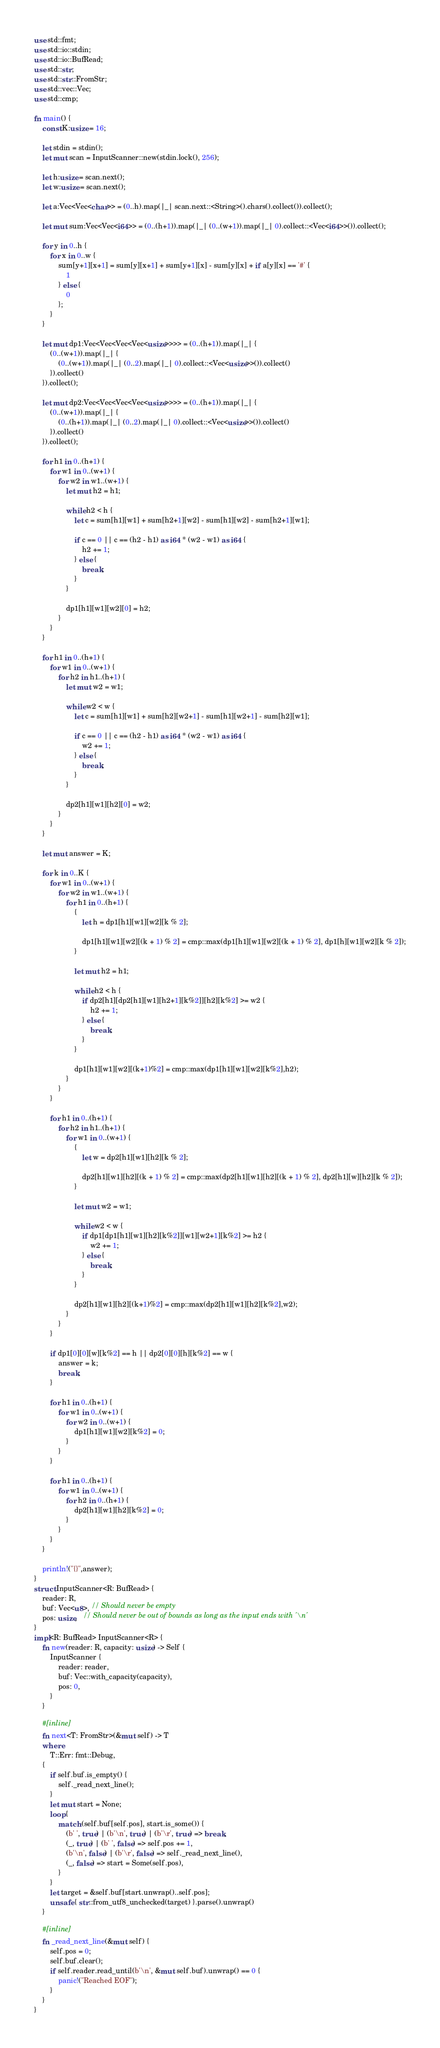Convert code to text. <code><loc_0><loc_0><loc_500><loc_500><_Rust_>use std::fmt;
use std::io::stdin;
use std::io::BufRead;
use std::str;
use std::str::FromStr;
use std::vec::Vec;
use std::cmp;

fn main() {
    const K:usize = 16;

    let stdin = stdin();
    let mut scan = InputScanner::new(stdin.lock(), 256);

    let h:usize = scan.next();
    let w:usize = scan.next();

    let a:Vec<Vec<char>> = (0..h).map(|_| scan.next::<String>().chars().collect()).collect();

    let mut sum:Vec<Vec<i64>> = (0..(h+1)).map(|_| (0..(w+1)).map(|_| 0).collect::<Vec<i64>>()).collect();

    for y in 0..h {
        for x in 0..w {
            sum[y+1][x+1] = sum[y][x+1] + sum[y+1][x] - sum[y][x] + if a[y][x] == '#' {
                1
            } else {
                0
            };
        }
    }

    let mut dp1:Vec<Vec<Vec<Vec<usize>>>> = (0..(h+1)).map(|_| {
        (0..(w+1)).map(|_| {
            (0..(w+1)).map(|_| (0..2).map(|_| 0).collect::<Vec<usize>>()).collect()
        }).collect()
    }).collect();

    let mut dp2:Vec<Vec<Vec<Vec<usize>>>> = (0..(h+1)).map(|_| {
        (0..(w+1)).map(|_| {
            (0..(h+1)).map(|_| (0..2).map(|_| 0).collect::<Vec<usize>>()).collect()
        }).collect()
    }).collect();

    for h1 in 0..(h+1) {
        for w1 in 0..(w+1) {
            for w2 in w1..(w+1) {
                let mut h2 = h1;

                while h2 < h {
                    let c = sum[h1][w1] + sum[h2+1][w2] - sum[h1][w2] - sum[h2+1][w1];

                    if c == 0 || c == (h2 - h1) as i64 * (w2 - w1) as i64 {
                        h2 += 1;
                    } else {
                        break;
                    }
                }

                dp1[h1][w1][w2][0] = h2;
            }
        }
    }

    for h1 in 0..(h+1) {
        for w1 in 0..(w+1) {
            for h2 in h1..(h+1) {
                let mut w2 = w1;

                while w2 < w {
                    let c = sum[h1][w1] + sum[h2][w2+1] - sum[h1][w2+1] - sum[h2][w1];

                    if c == 0 || c == (h2 - h1) as i64 * (w2 - w1) as i64 {
                        w2 += 1;
                    } else {
                        break;
                    }
                }

                dp2[h1][w1][h2][0] = w2;
            }
        }
    }

    let mut answer = K;

    for k in 0..K {
        for w1 in 0..(w+1) {
            for w2 in w1..(w+1) {
                for h1 in 0..(h+1) {
                    {
                        let h = dp1[h1][w1][w2][k % 2];

                        dp1[h1][w1][w2][(k + 1) % 2] = cmp::max(dp1[h1][w1][w2][(k + 1) % 2], dp1[h][w1][w2][k % 2]);
                    }

                    let mut h2 = h1;

                    while h2 < h {
                        if dp2[h1][dp2[h1][w1][h2+1][k%2]][h2][k%2] >= w2 {
                            h2 += 1;
                        } else {
                            break;
                        }
                    }

                    dp1[h1][w1][w2][(k+1)%2] = cmp::max(dp1[h1][w1][w2][k%2],h2);
                }
            }
        }

        for h1 in 0..(h+1) {
            for h2 in h1..(h+1) {
                for w1 in 0..(w+1) {
                    {
                        let w = dp2[h1][w1][h2][k % 2];

                        dp2[h1][w1][h2][(k + 1) % 2] = cmp::max(dp2[h1][w1][h2][(k + 1) % 2], dp2[h1][w][h2][k % 2]);
                    }

                    let mut w2 = w1;

                    while w2 < w {
                        if dp1[dp1[h1][w1][h2][k%2]][w1][w2+1][k%2] >= h2 {
                            w2 += 1;
                        } else {
                            break;
                        }
                    }

                    dp2[h1][w1][h2][(k+1)%2] = cmp::max(dp2[h1][w1][h2][k%2],w2);
                }
            }
        }

        if dp1[0][0][w][k%2] == h || dp2[0][0][h][k%2] == w {
            answer = k;
            break;
        }

        for h1 in 0..(h+1) {
            for w1 in 0..(w+1) {
                for w2 in 0..(w+1) {
                    dp1[h1][w1][w2][k%2] = 0;
                }
            }
        }

        for h1 in 0..(h+1) {
            for w1 in 0..(w+1) {
                for h2 in 0..(h+1) {
                    dp2[h1][w1][h2][k%2] = 0;
                }
            }
        }
    }

    println!("{}",answer);
}
struct InputScanner<R: BufRead> {
	reader: R,
	buf: Vec<u8>, // Should never be empty
	pos: usize,   // Should never be out of bounds as long as the input ends with '\n'
}
impl<R: BufRead> InputScanner<R> {
	fn new(reader: R, capacity: usize) -> Self {
		InputScanner {
			reader: reader,
			buf: Vec::with_capacity(capacity),
			pos: 0,
		}
	}

	#[inline]
	fn next<T: FromStr>(&mut self) -> T
	where
		T::Err: fmt::Debug,
	{
		if self.buf.is_empty() {
			self._read_next_line();
		}
		let mut start = None;
		loop {
			match (self.buf[self.pos], start.is_some()) {
				(b' ', true) | (b'\n', true) | (b'\r', true) => break,
				(_, true) | (b' ', false) => self.pos += 1,
				(b'\n', false) | (b'\r', false) => self._read_next_line(),
				(_, false) => start = Some(self.pos),
			}
		}
		let target = &self.buf[start.unwrap()..self.pos];
		unsafe { str::from_utf8_unchecked(target) }.parse().unwrap()
	}

	#[inline]
	fn _read_next_line(&mut self) {
		self.pos = 0;
		self.buf.clear();
		if self.reader.read_until(b'\n', &mut self.buf).unwrap() == 0 {
			panic!("Reached EOF");
		}
	}
}

</code> 